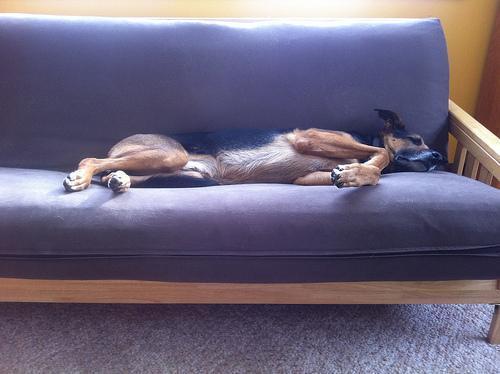How many animals are there?
Give a very brief answer. 1. 